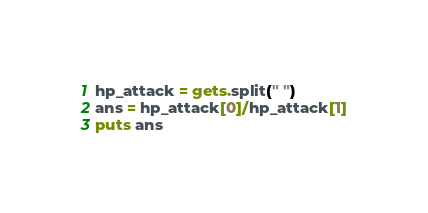<code> <loc_0><loc_0><loc_500><loc_500><_Ruby_>hp_attack = gets.split(" ")
ans = hp_attack[0]/hp_attack[1]
puts ans</code> 